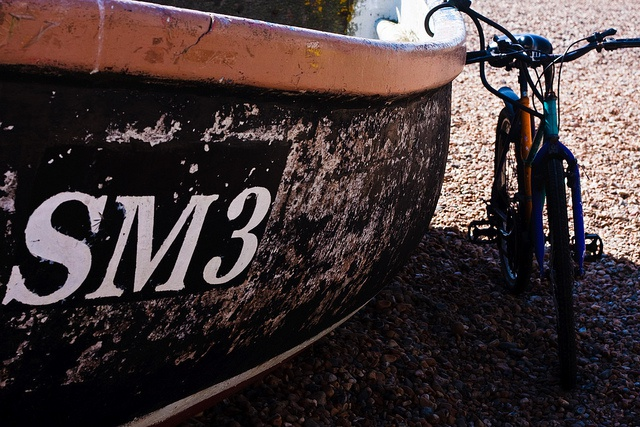Describe the objects in this image and their specific colors. I can see boat in purple, black, brown, and darkgray tones and bicycle in purple, black, lightgray, navy, and pink tones in this image. 